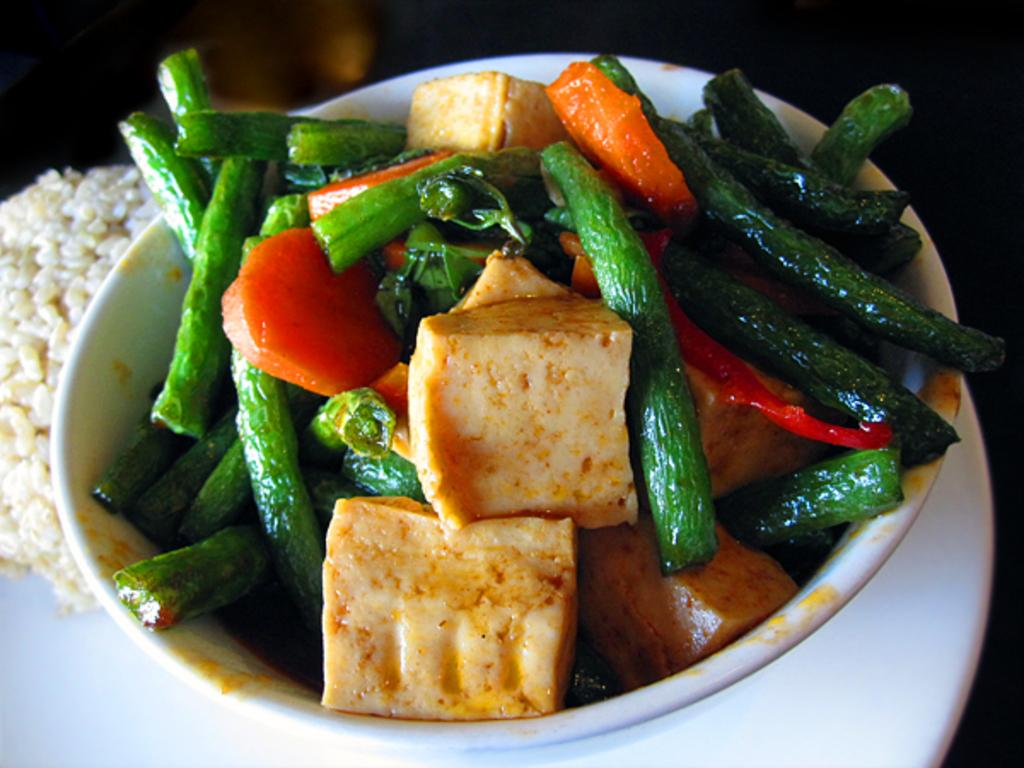What type of plate is in the image? There is a white color plate in the image. What is on the plate? There is a bowl with vegetable slices in the image. What types of vegetables are included in the slices? The vegetable slices include beans and carrots. What else can be seen on the plate? There is rice visible in the image. What advice does the queen give to the person eating the vegetables in the image? There is no queen present in the image, and therefore no advice can be given. 